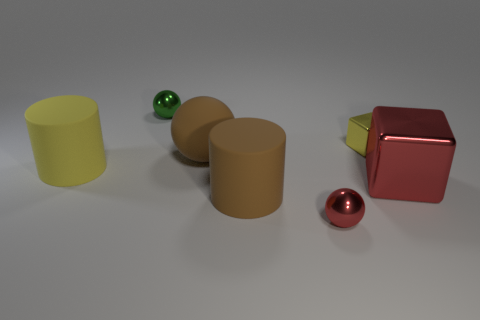Are the big yellow object and the big sphere made of the same material?
Offer a terse response. Yes. How many spheres are large red metal objects or rubber things?
Provide a succinct answer. 1. There is a yellow thing that is right of the tiny shiny ball behind the small ball on the right side of the small green object; what is its size?
Your response must be concise. Small. There is a green thing that is the same shape as the small red metal object; what size is it?
Give a very brief answer. Small. How many tiny yellow metallic objects are in front of the tiny red metal thing?
Your answer should be very brief. 0. Do the tiny metallic sphere in front of the yellow matte cylinder and the large metallic cube have the same color?
Ensure brevity in your answer.  Yes. How many brown objects are either cylinders or metallic spheres?
Offer a terse response. 1. What color is the tiny ball left of the large brown object that is behind the large brown cylinder?
Offer a very short reply. Green. What material is the big object that is the same color as the big sphere?
Offer a very short reply. Rubber. The small metallic cube that is behind the red cube is what color?
Give a very brief answer. Yellow. 